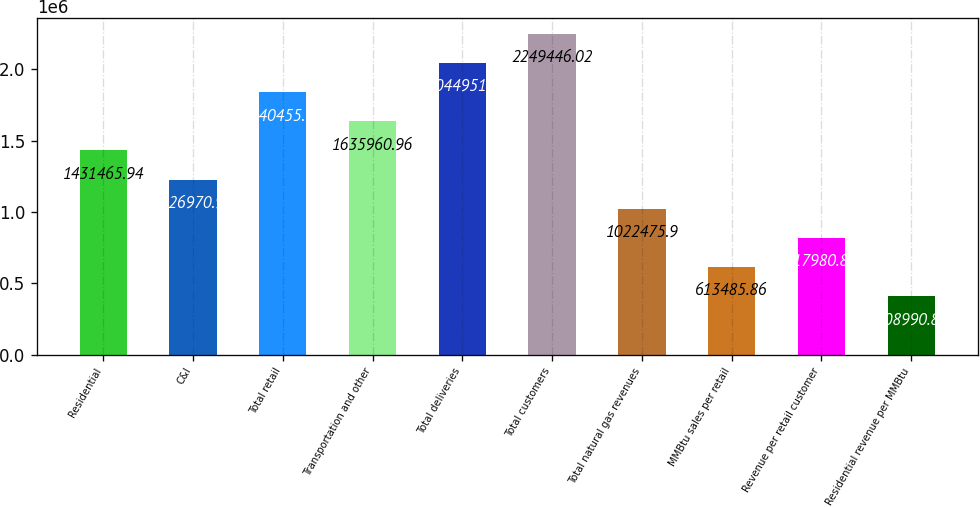Convert chart to OTSL. <chart><loc_0><loc_0><loc_500><loc_500><bar_chart><fcel>Residential<fcel>C&I<fcel>Total retail<fcel>Transportation and other<fcel>Total deliveries<fcel>Total customers<fcel>Total natural gas revenues<fcel>MMBtu sales per retail<fcel>Revenue per retail customer<fcel>Residential revenue per MMBtu<nl><fcel>1.43147e+06<fcel>1.22697e+06<fcel>1.84046e+06<fcel>1.63596e+06<fcel>2.04495e+06<fcel>2.24945e+06<fcel>1.02248e+06<fcel>613486<fcel>817981<fcel>408991<nl></chart> 